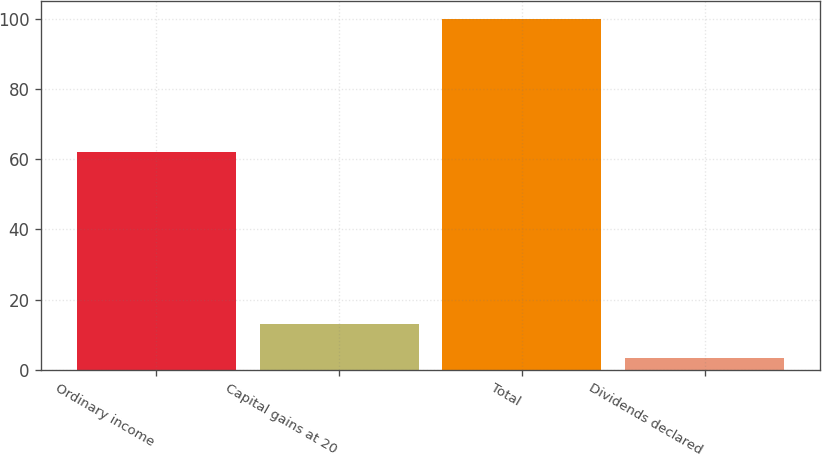Convert chart. <chart><loc_0><loc_0><loc_500><loc_500><bar_chart><fcel>Ordinary income<fcel>Capital gains at 20<fcel>Total<fcel>Dividends declared<nl><fcel>62.1<fcel>13.11<fcel>100<fcel>3.45<nl></chart> 